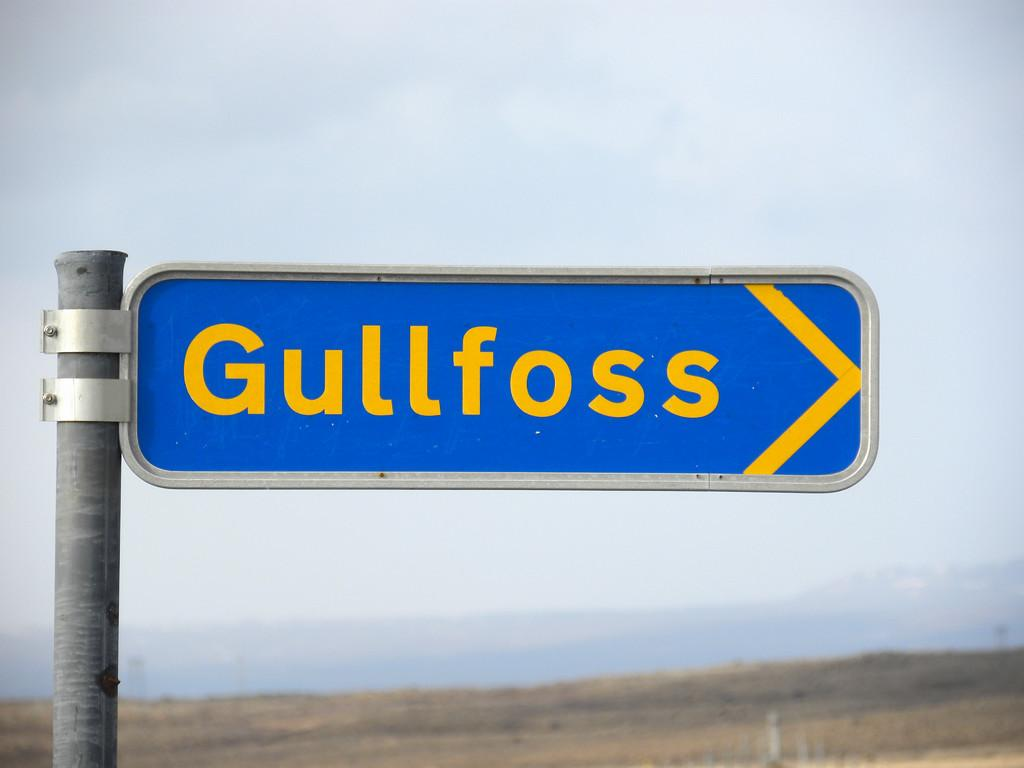<image>
Create a compact narrative representing the image presented. A sign with the word Gullfoss on it pointing right. 